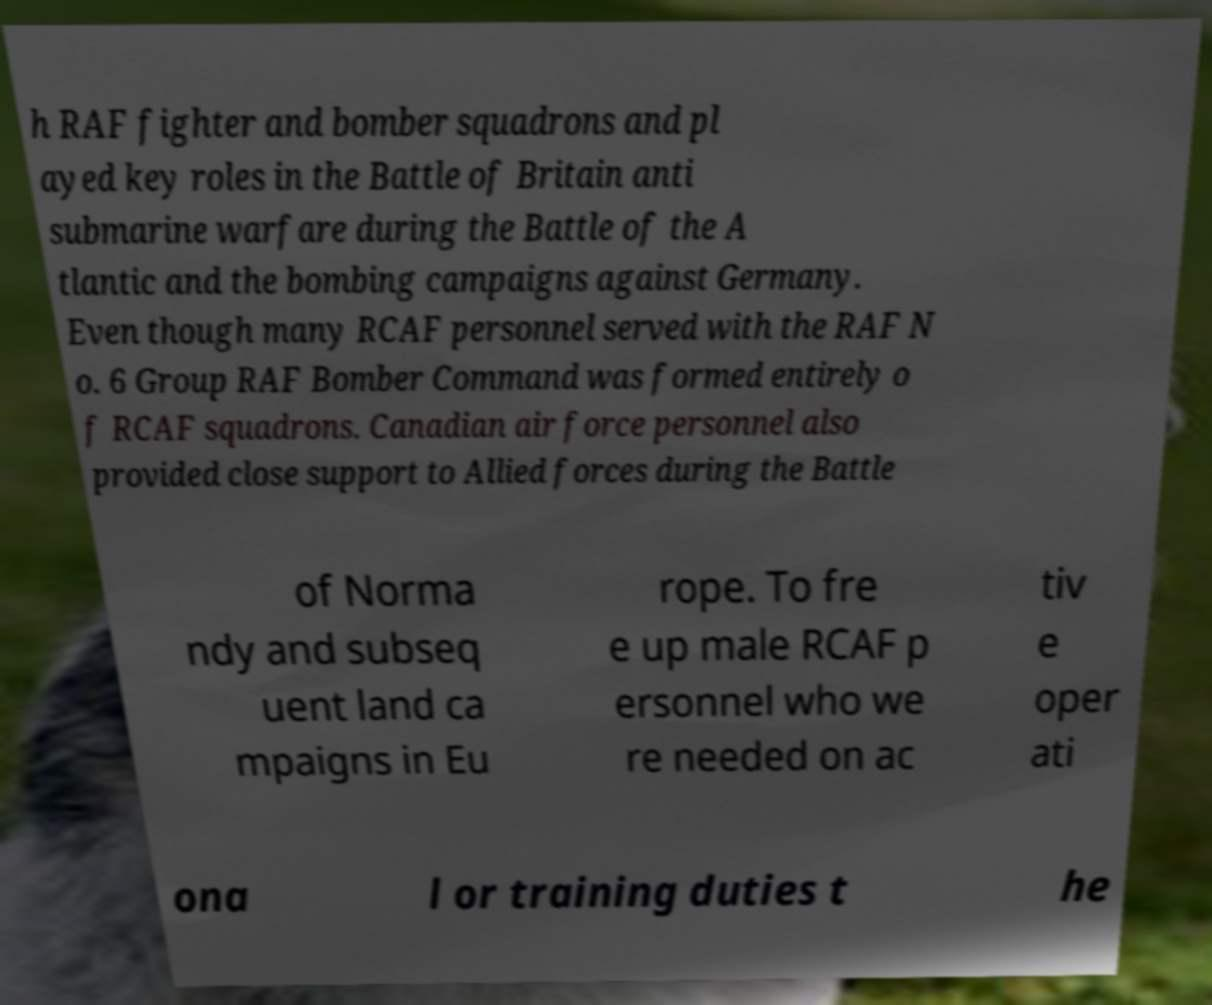For documentation purposes, I need the text within this image transcribed. Could you provide that? h RAF fighter and bomber squadrons and pl ayed key roles in the Battle of Britain anti submarine warfare during the Battle of the A tlantic and the bombing campaigns against Germany. Even though many RCAF personnel served with the RAF N o. 6 Group RAF Bomber Command was formed entirely o f RCAF squadrons. Canadian air force personnel also provided close support to Allied forces during the Battle of Norma ndy and subseq uent land ca mpaigns in Eu rope. To fre e up male RCAF p ersonnel who we re needed on ac tiv e oper ati ona l or training duties t he 